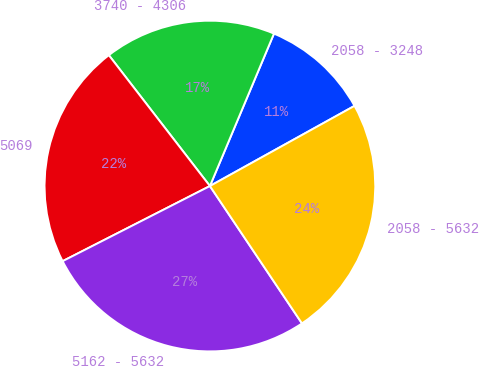Convert chart. <chart><loc_0><loc_0><loc_500><loc_500><pie_chart><fcel>2058 - 3248<fcel>3740 - 4306<fcel>5069<fcel>5162 - 5632<fcel>2058 - 5632<nl><fcel>10.61%<fcel>16.8%<fcel>22.04%<fcel>26.89%<fcel>23.66%<nl></chart> 